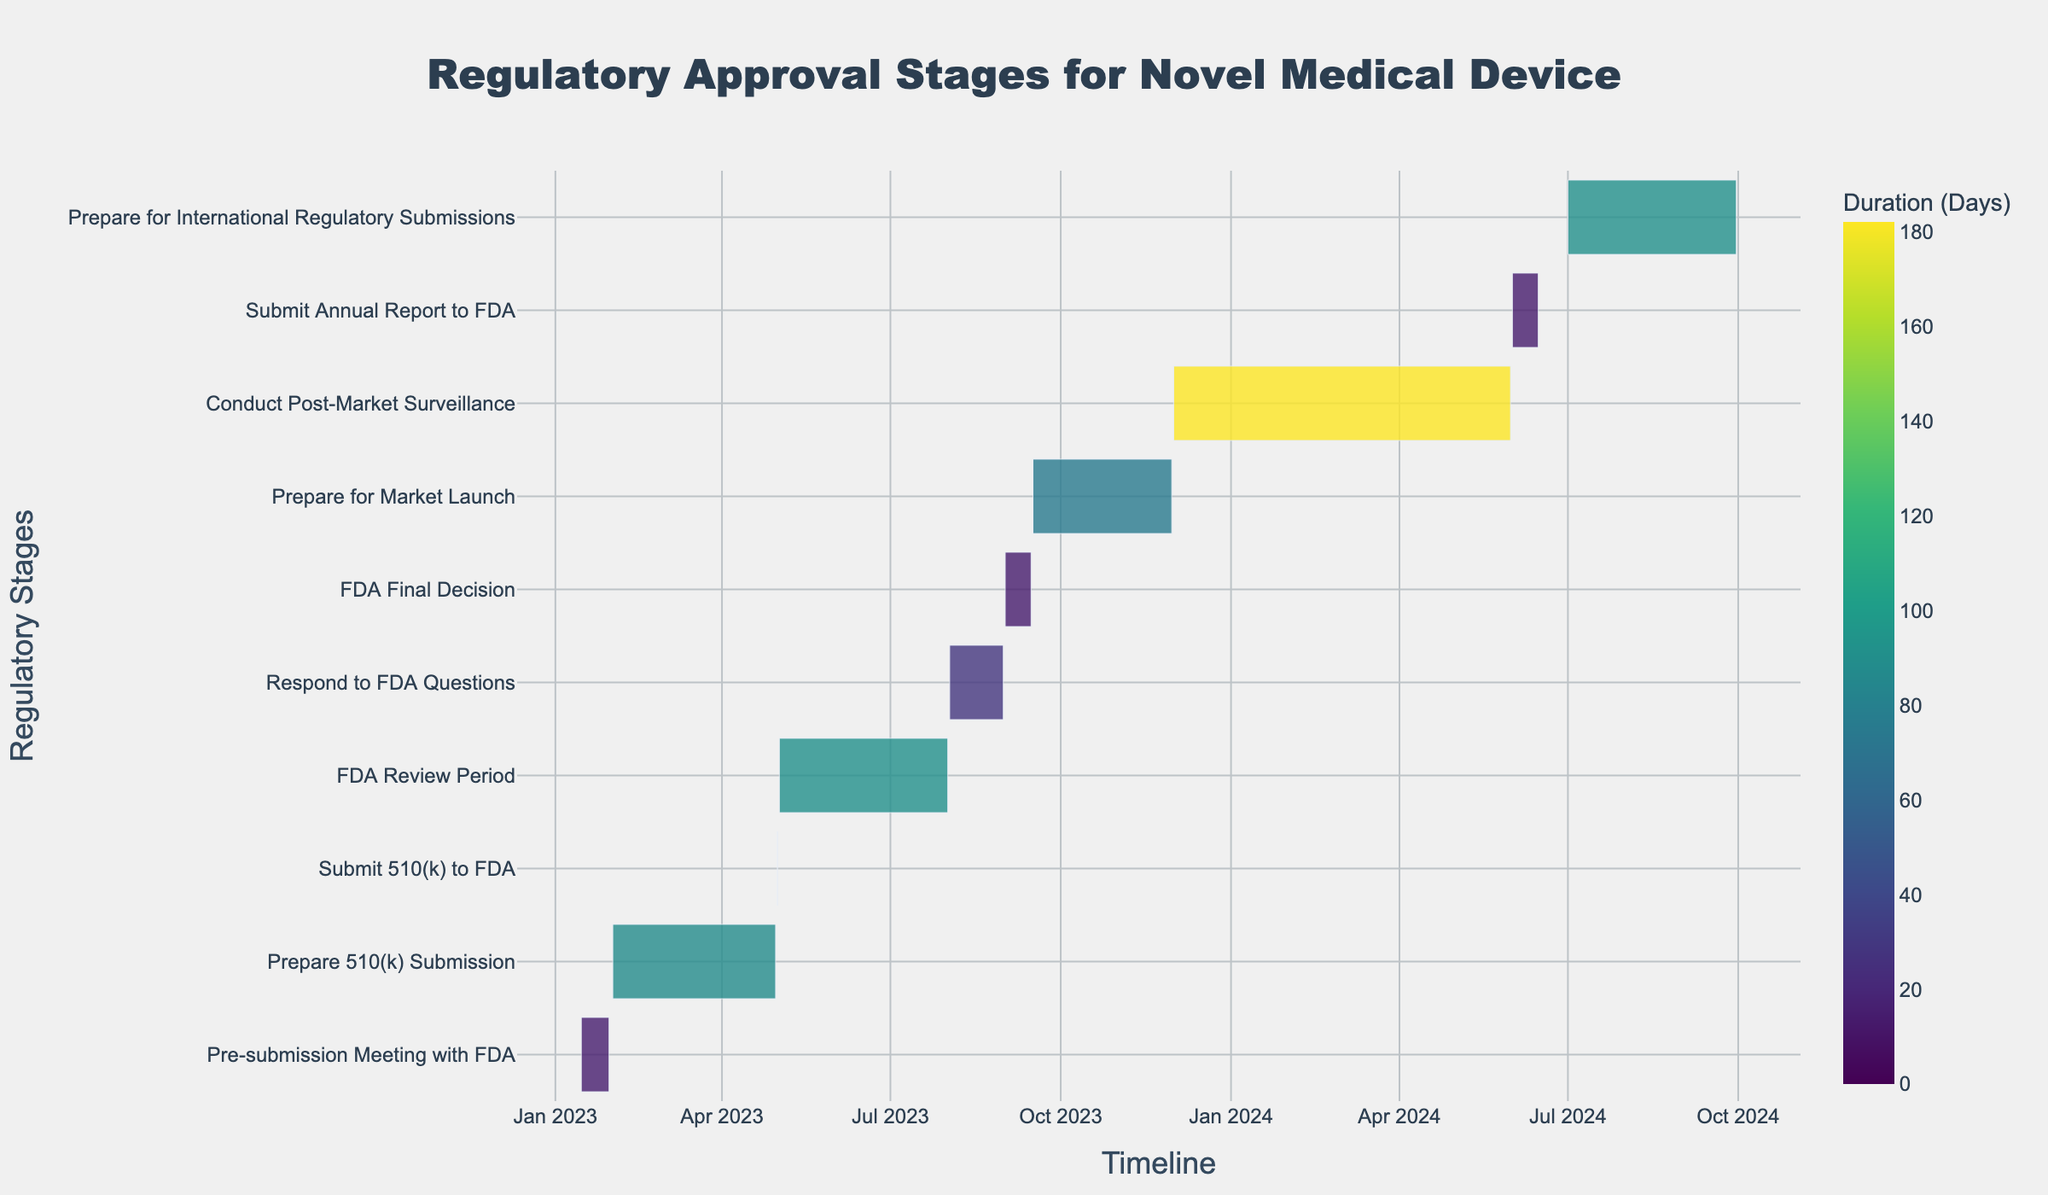What is the title of the Gantt chart? The title of the Gantt chart is generally found at the top of the figure and is usually formatted in a larger or bold font to stand out. In this case, the title indicates the overall topic of the chart.
Answer: Regulatory Approval Stages for Novel Medical Device When does the "FDA Review Period" start and end? To determine the start and end dates for the "FDA Review Period," locate the corresponding bar in the Gantt chart and refer to its positioned dates. These dates precisely mark the task duration on the timeline.
Answer: 2023-05-02 to 2023-08-01 Which task takes the longest duration, and how long is it? To identify the task with the longest duration, look for the longest bar in the Gantt chart. The duration of each task is usually shown by the length of its bar, and the specific duration can be read from the hover information or color scale.
Answer: Prepare 510(k) Submission, 89 days How many days are allocated to "Prepare for Market Launch"? The duration of a specific task can be inferred from the hover information or a separate duration indicator on the bar of the task. This information reveals how long the task is scheduled to take.
Answer: 76 days What tasks are set to start in 2024? To determine which tasks start in a specific year, scan the timeline axis for the year mark and find the tasks that originate from that point. Focus on tasks with their start dates falling within 2024.
Answer: Conduct Post-Market Surveillance, Submit Annual Report to FDA, Prepare for International Regulatory Submissions Which task follows immediately after "Submit 510(k) to FDA"? To figure out which task follows immediately after another, locate the end date of the specified task and determine which subsequent task starts immediately or has the earliest start date following the end date.
Answer: FDA Review Period What is the duration difference between "FDA Final Decision" and "Prepare for Market Launch"? First, calculate the duration of each task by finding the difference between their start and end dates, then subtract one duration from the other to get the difference.
Answer: 74 days (Prepare for Market Launch is longer by 76 days - 2 days = 74 days) Are there any tasks that overlap with the "Respond to FDA Questions" period? Check the timeline to see if any task bars intersect or overlap with the period indicated for "Respond to FDA Questions." This will indicate concurrent activities.
Answer: No How many tasks are planned for the post-market phase? Tasks in the post-market phase can be identified by looking for tasks that start after the initial market launch. Count the relevant tasks appearing after this milestone on the timeline.
Answer: 3 tasks (Conduct Post-Market Surveillance, Submit Annual Report to FDA, Prepare for International Regulatory Submissions) What is the average duration of all tasks? Calculate the duration of each task by subtracting the start date from the end date for all tasks. Sum these durations and divide by the number of tasks to find the average duration.
Answer: (15 + 89 + 1 + 91 + 29 + 15 + 76 + 182 + 15 + 92) / 10 = 60 days 